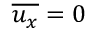Convert formula to latex. <formula><loc_0><loc_0><loc_500><loc_500>\overline { { u _ { x } } } = 0</formula> 